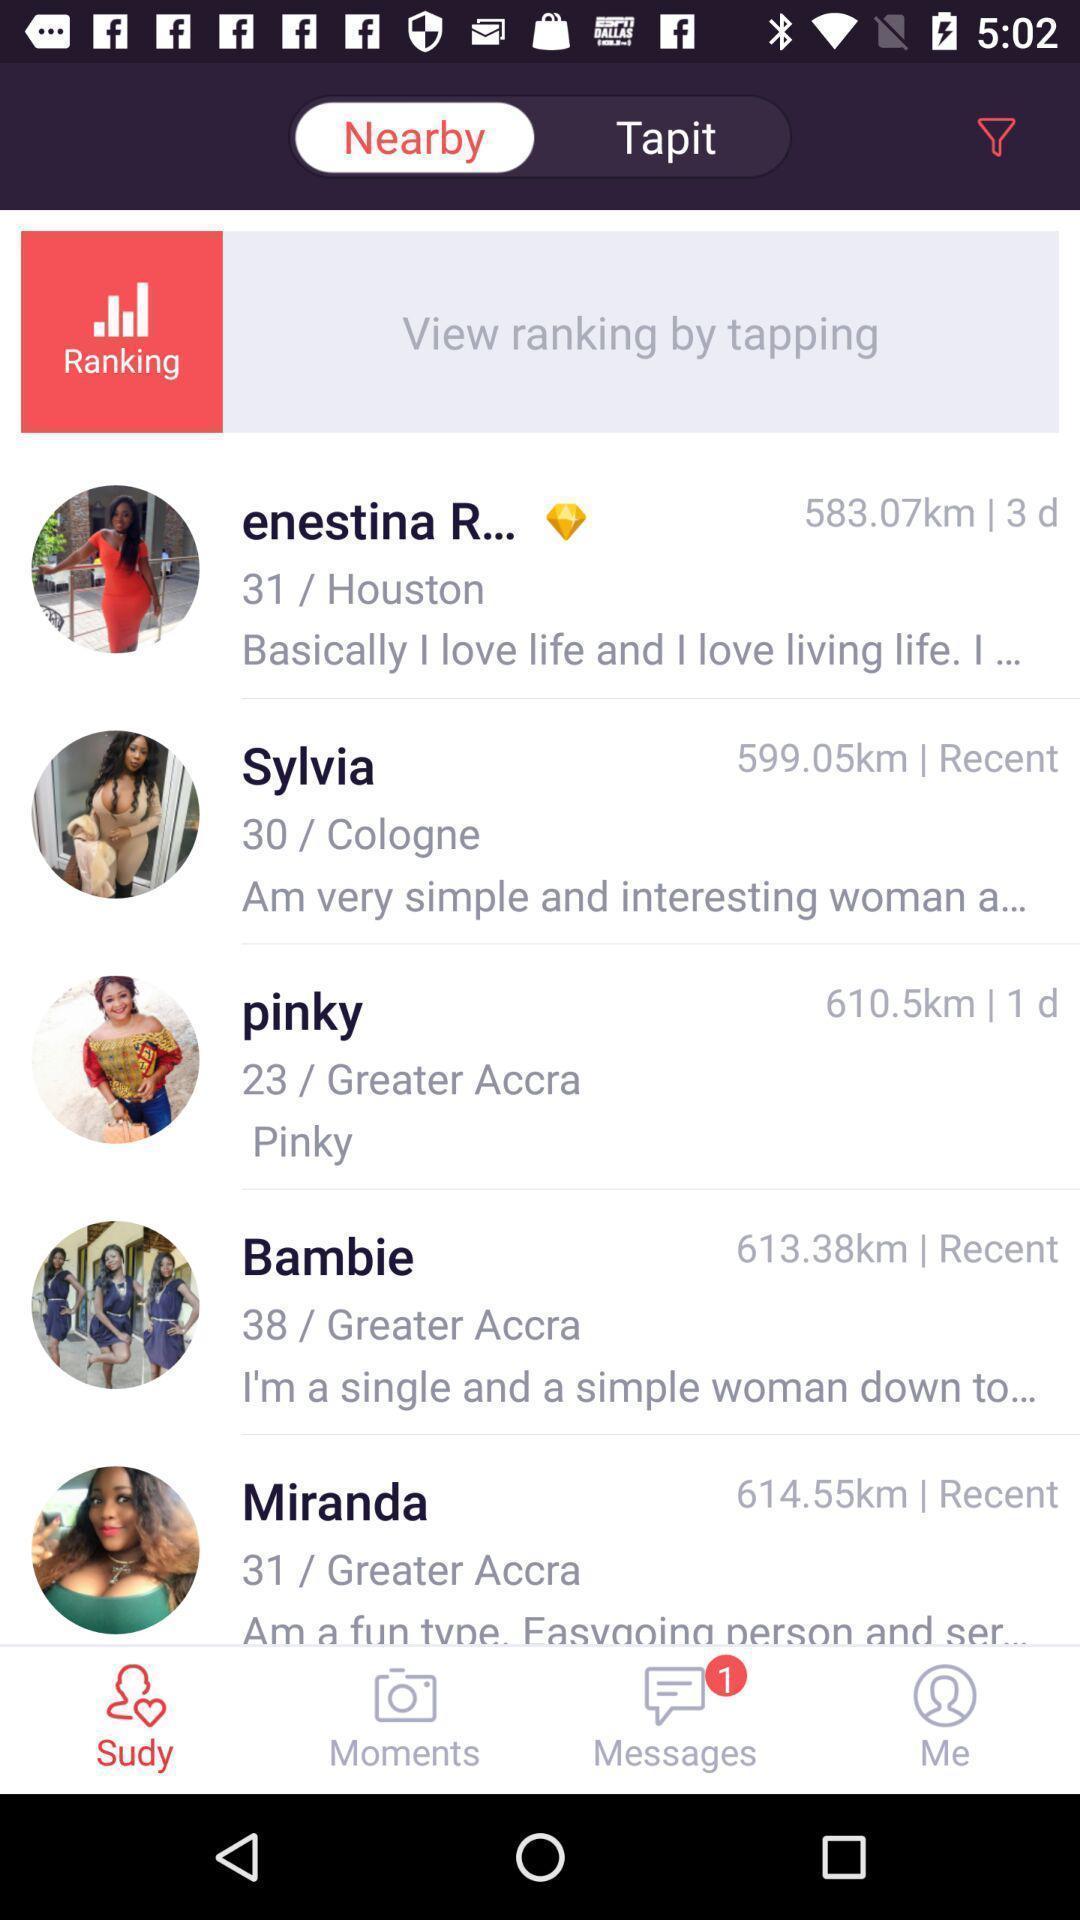Please provide a description for this image. Screen showing list of various contacts. 